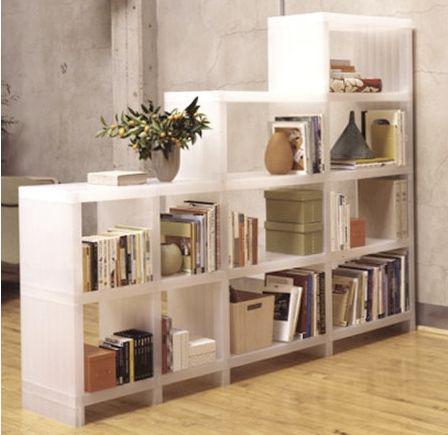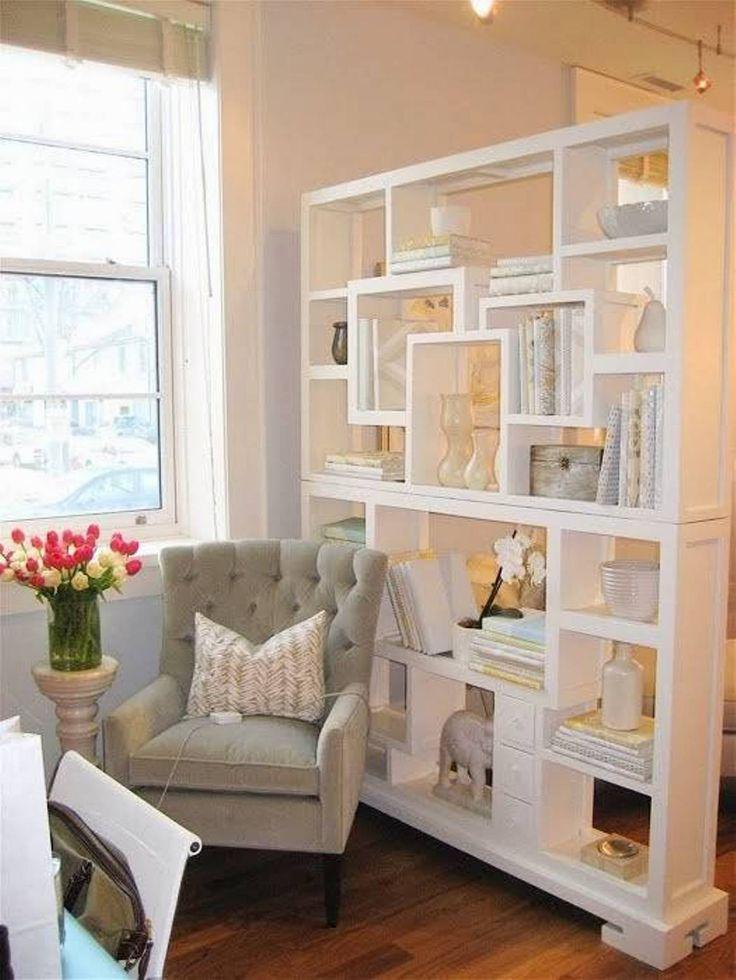The first image is the image on the left, the second image is the image on the right. Given the left and right images, does the statement "One of the bookshelves has decorative items on top as well as on the shelves." hold true? Answer yes or no. Yes. The first image is the image on the left, the second image is the image on the right. For the images shown, is this caption "In each image, a wide white shelving unit is placed perpendicular to a wall to create a room divider." true? Answer yes or no. Yes. 